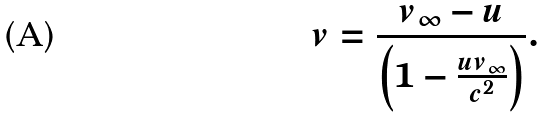Convert formula to latex. <formula><loc_0><loc_0><loc_500><loc_500>v = \frac { v _ { \infty } - u } { \left ( 1 - \frac { u v _ { \infty } } { c ^ { 2 } } \right ) } .</formula> 